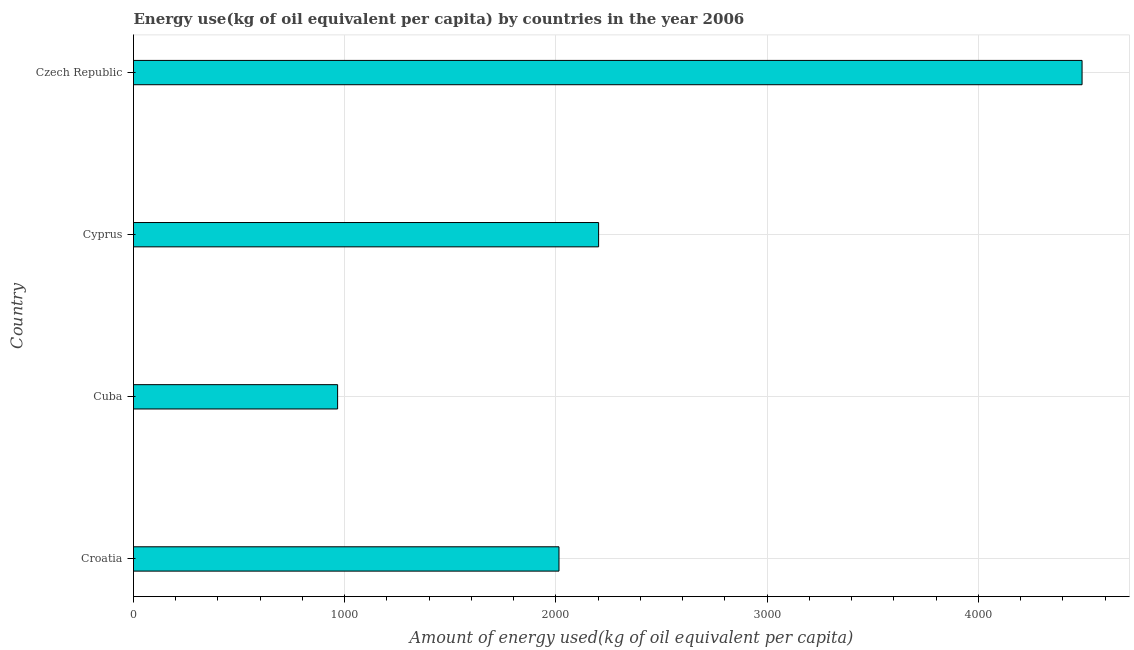Does the graph contain any zero values?
Make the answer very short. No. Does the graph contain grids?
Make the answer very short. Yes. What is the title of the graph?
Ensure brevity in your answer.  Energy use(kg of oil equivalent per capita) by countries in the year 2006. What is the label or title of the X-axis?
Offer a very short reply. Amount of energy used(kg of oil equivalent per capita). What is the label or title of the Y-axis?
Your answer should be very brief. Country. What is the amount of energy used in Cuba?
Provide a short and direct response. 966.35. Across all countries, what is the maximum amount of energy used?
Provide a short and direct response. 4491.11. Across all countries, what is the minimum amount of energy used?
Make the answer very short. 966.35. In which country was the amount of energy used maximum?
Give a very brief answer. Czech Republic. In which country was the amount of energy used minimum?
Provide a short and direct response. Cuba. What is the sum of the amount of energy used?
Provide a short and direct response. 9674.07. What is the difference between the amount of energy used in Cuba and Cyprus?
Keep it short and to the point. -1235.73. What is the average amount of energy used per country?
Your answer should be compact. 2418.52. What is the median amount of energy used?
Offer a very short reply. 2108.3. In how many countries, is the amount of energy used greater than 2800 kg?
Ensure brevity in your answer.  1. What is the ratio of the amount of energy used in Cuba to that in Czech Republic?
Provide a succinct answer. 0.21. Is the amount of energy used in Cuba less than that in Czech Republic?
Your answer should be very brief. Yes. What is the difference between the highest and the second highest amount of energy used?
Provide a succinct answer. 2289.03. What is the difference between the highest and the lowest amount of energy used?
Provide a succinct answer. 3524.76. In how many countries, is the amount of energy used greater than the average amount of energy used taken over all countries?
Offer a very short reply. 1. Are all the bars in the graph horizontal?
Ensure brevity in your answer.  Yes. How many countries are there in the graph?
Your response must be concise. 4. What is the difference between two consecutive major ticks on the X-axis?
Ensure brevity in your answer.  1000. Are the values on the major ticks of X-axis written in scientific E-notation?
Your answer should be compact. No. What is the Amount of energy used(kg of oil equivalent per capita) of Croatia?
Offer a terse response. 2014.52. What is the Amount of energy used(kg of oil equivalent per capita) of Cuba?
Keep it short and to the point. 966.35. What is the Amount of energy used(kg of oil equivalent per capita) of Cyprus?
Keep it short and to the point. 2202.08. What is the Amount of energy used(kg of oil equivalent per capita) in Czech Republic?
Ensure brevity in your answer.  4491.11. What is the difference between the Amount of energy used(kg of oil equivalent per capita) in Croatia and Cuba?
Make the answer very short. 1048.17. What is the difference between the Amount of energy used(kg of oil equivalent per capita) in Croatia and Cyprus?
Ensure brevity in your answer.  -187.56. What is the difference between the Amount of energy used(kg of oil equivalent per capita) in Croatia and Czech Republic?
Your answer should be compact. -2476.59. What is the difference between the Amount of energy used(kg of oil equivalent per capita) in Cuba and Cyprus?
Offer a very short reply. -1235.73. What is the difference between the Amount of energy used(kg of oil equivalent per capita) in Cuba and Czech Republic?
Offer a terse response. -3524.76. What is the difference between the Amount of energy used(kg of oil equivalent per capita) in Cyprus and Czech Republic?
Make the answer very short. -2289.03. What is the ratio of the Amount of energy used(kg of oil equivalent per capita) in Croatia to that in Cuba?
Your response must be concise. 2.08. What is the ratio of the Amount of energy used(kg of oil equivalent per capita) in Croatia to that in Cyprus?
Offer a terse response. 0.92. What is the ratio of the Amount of energy used(kg of oil equivalent per capita) in Croatia to that in Czech Republic?
Provide a succinct answer. 0.45. What is the ratio of the Amount of energy used(kg of oil equivalent per capita) in Cuba to that in Cyprus?
Your answer should be compact. 0.44. What is the ratio of the Amount of energy used(kg of oil equivalent per capita) in Cuba to that in Czech Republic?
Make the answer very short. 0.21. What is the ratio of the Amount of energy used(kg of oil equivalent per capita) in Cyprus to that in Czech Republic?
Keep it short and to the point. 0.49. 